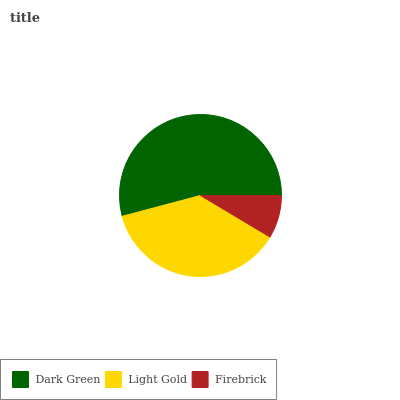Is Firebrick the minimum?
Answer yes or no. Yes. Is Dark Green the maximum?
Answer yes or no. Yes. Is Light Gold the minimum?
Answer yes or no. No. Is Light Gold the maximum?
Answer yes or no. No. Is Dark Green greater than Light Gold?
Answer yes or no. Yes. Is Light Gold less than Dark Green?
Answer yes or no. Yes. Is Light Gold greater than Dark Green?
Answer yes or no. No. Is Dark Green less than Light Gold?
Answer yes or no. No. Is Light Gold the high median?
Answer yes or no. Yes. Is Light Gold the low median?
Answer yes or no. Yes. Is Firebrick the high median?
Answer yes or no. No. Is Firebrick the low median?
Answer yes or no. No. 